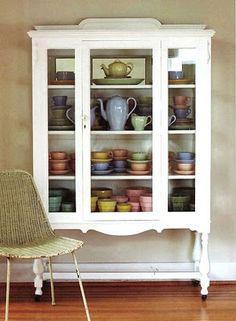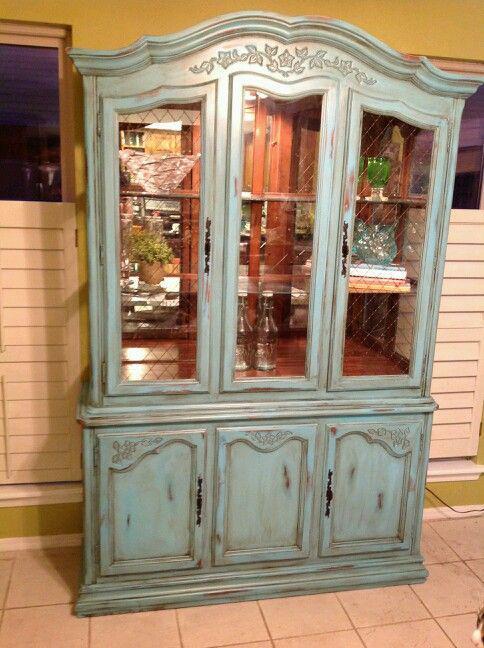The first image is the image on the left, the second image is the image on the right. Analyze the images presented: Is the assertion "All of the cabinets pictured have flat tops instead of curved tops." valid? Answer yes or no. No. The first image is the image on the left, the second image is the image on the right. Examine the images to the left and right. Is the description "There is a chair set up near a white cabinet." accurate? Answer yes or no. Yes. 